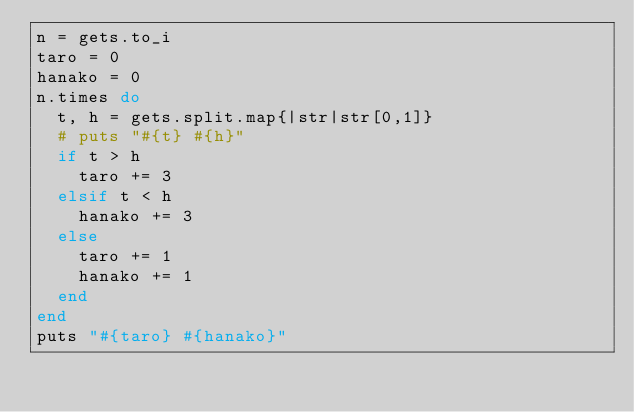<code> <loc_0><loc_0><loc_500><loc_500><_Ruby_>n = gets.to_i
taro = 0
hanako = 0
n.times do
  t, h = gets.split.map{|str|str[0,1]}
  # puts "#{t} #{h}"
  if t > h
    taro += 3
  elsif t < h
    hanako += 3
  else
    taro += 1
    hanako += 1
  end
end
puts "#{taro} #{hanako}"</code> 